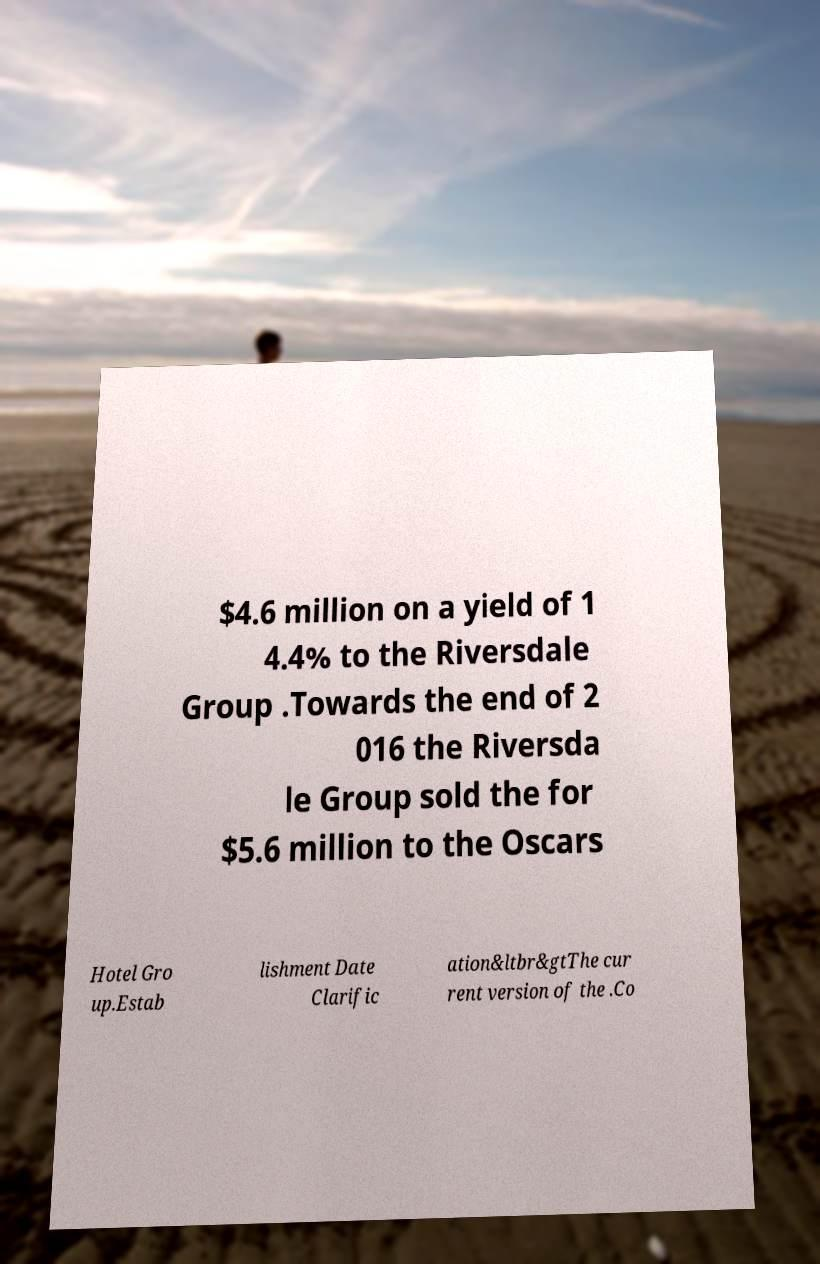What messages or text are displayed in this image? I need them in a readable, typed format. $4.6 million on a yield of 1 4.4% to the Riversdale Group .Towards the end of 2 016 the Riversda le Group sold the for $5.6 million to the Oscars Hotel Gro up.Estab lishment Date Clarific ation&ltbr&gtThe cur rent version of the .Co 